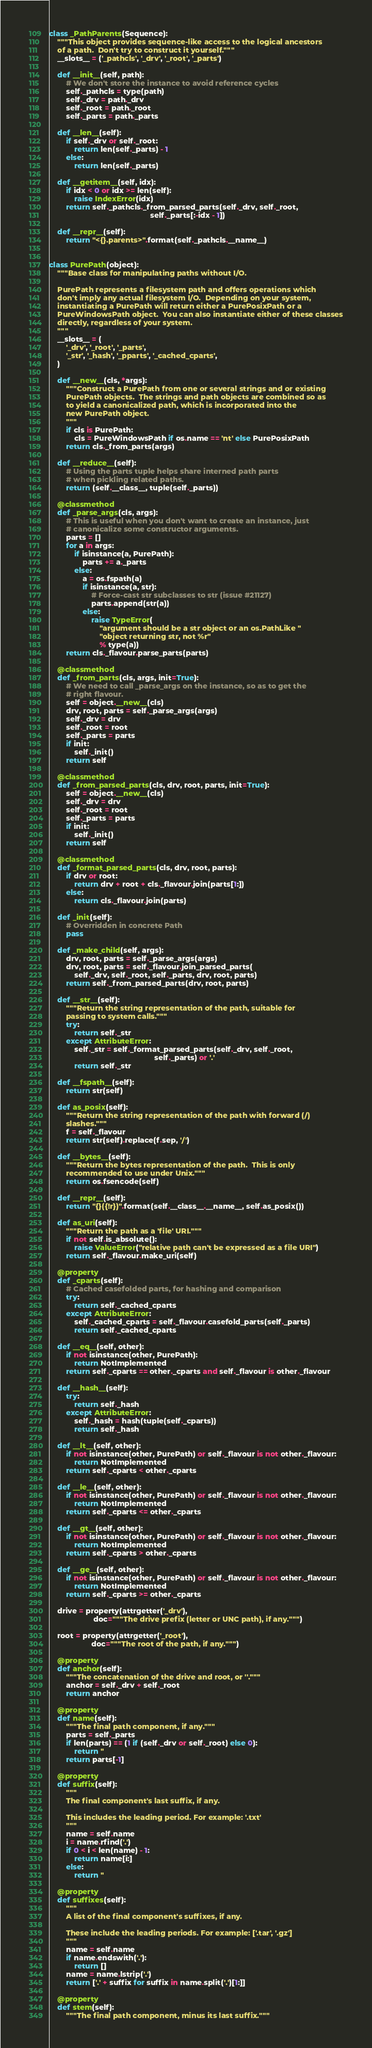Convert code to text. <code><loc_0><loc_0><loc_500><loc_500><_Python_>
class _PathParents(Sequence):
    """This object provides sequence-like access to the logical ancestors
    of a path.  Don't try to construct it yourself."""
    __slots__ = ('_pathcls', '_drv', '_root', '_parts')

    def __init__(self, path):
        # We don't store the instance to avoid reference cycles
        self._pathcls = type(path)
        self._drv = path._drv
        self._root = path._root
        self._parts = path._parts

    def __len__(self):
        if self._drv or self._root:
            return len(self._parts) - 1
        else:
            return len(self._parts)

    def __getitem__(self, idx):
        if idx < 0 or idx >= len(self):
            raise IndexError(idx)
        return self._pathcls._from_parsed_parts(self._drv, self._root,
                                                self._parts[:-idx - 1])

    def __repr__(self):
        return "<{}.parents>".format(self._pathcls.__name__)


class PurePath(object):
    """Base class for manipulating paths without I/O.

    PurePath represents a filesystem path and offers operations which
    don't imply any actual filesystem I/O.  Depending on your system,
    instantiating a PurePath will return either a PurePosixPath or a
    PureWindowsPath object.  You can also instantiate either of these classes
    directly, regardless of your system.
    """
    __slots__ = (
        '_drv', '_root', '_parts',
        '_str', '_hash', '_pparts', '_cached_cparts',
    )

    def __new__(cls, *args):
        """Construct a PurePath from one or several strings and or existing
        PurePath objects.  The strings and path objects are combined so as
        to yield a canonicalized path, which is incorporated into the
        new PurePath object.
        """
        if cls is PurePath:
            cls = PureWindowsPath if os.name == 'nt' else PurePosixPath
        return cls._from_parts(args)

    def __reduce__(self):
        # Using the parts tuple helps share interned path parts
        # when pickling related paths.
        return (self.__class__, tuple(self._parts))

    @classmethod
    def _parse_args(cls, args):
        # This is useful when you don't want to create an instance, just
        # canonicalize some constructor arguments.
        parts = []
        for a in args:
            if isinstance(a, PurePath):
                parts += a._parts
            else:
                a = os.fspath(a)
                if isinstance(a, str):
                    # Force-cast str subclasses to str (issue #21127)
                    parts.append(str(a))
                else:
                    raise TypeError(
                        "argument should be a str object or an os.PathLike "
                        "object returning str, not %r"
                        % type(a))
        return cls._flavour.parse_parts(parts)

    @classmethod
    def _from_parts(cls, args, init=True):
        # We need to call _parse_args on the instance, so as to get the
        # right flavour.
        self = object.__new__(cls)
        drv, root, parts = self._parse_args(args)
        self._drv = drv
        self._root = root
        self._parts = parts
        if init:
            self._init()
        return self

    @classmethod
    def _from_parsed_parts(cls, drv, root, parts, init=True):
        self = object.__new__(cls)
        self._drv = drv
        self._root = root
        self._parts = parts
        if init:
            self._init()
        return self

    @classmethod
    def _format_parsed_parts(cls, drv, root, parts):
        if drv or root:
            return drv + root + cls._flavour.join(parts[1:])
        else:
            return cls._flavour.join(parts)

    def _init(self):
        # Overridden in concrete Path
        pass

    def _make_child(self, args):
        drv, root, parts = self._parse_args(args)
        drv, root, parts = self._flavour.join_parsed_parts(
            self._drv, self._root, self._parts, drv, root, parts)
        return self._from_parsed_parts(drv, root, parts)

    def __str__(self):
        """Return the string representation of the path, suitable for
        passing to system calls."""
        try:
            return self._str
        except AttributeError:
            self._str = self._format_parsed_parts(self._drv, self._root,
                                                  self._parts) or '.'
            return self._str

    def __fspath__(self):
        return str(self)

    def as_posix(self):
        """Return the string representation of the path with forward (/)
        slashes."""
        f = self._flavour
        return str(self).replace(f.sep, '/')

    def __bytes__(self):
        """Return the bytes representation of the path.  This is only
        recommended to use under Unix."""
        return os.fsencode(self)

    def __repr__(self):
        return "{}({!r})".format(self.__class__.__name__, self.as_posix())

    def as_uri(self):
        """Return the path as a 'file' URI."""
        if not self.is_absolute():
            raise ValueError("relative path can't be expressed as a file URI")
        return self._flavour.make_uri(self)

    @property
    def _cparts(self):
        # Cached casefolded parts, for hashing and comparison
        try:
            return self._cached_cparts
        except AttributeError:
            self._cached_cparts = self._flavour.casefold_parts(self._parts)
            return self._cached_cparts

    def __eq__(self, other):
        if not isinstance(other, PurePath):
            return NotImplemented
        return self._cparts == other._cparts and self._flavour is other._flavour

    def __hash__(self):
        try:
            return self._hash
        except AttributeError:
            self._hash = hash(tuple(self._cparts))
            return self._hash

    def __lt__(self, other):
        if not isinstance(other, PurePath) or self._flavour is not other._flavour:
            return NotImplemented
        return self._cparts < other._cparts

    def __le__(self, other):
        if not isinstance(other, PurePath) or self._flavour is not other._flavour:
            return NotImplemented
        return self._cparts <= other._cparts

    def __gt__(self, other):
        if not isinstance(other, PurePath) or self._flavour is not other._flavour:
            return NotImplemented
        return self._cparts > other._cparts

    def __ge__(self, other):
        if not isinstance(other, PurePath) or self._flavour is not other._flavour:
            return NotImplemented
        return self._cparts >= other._cparts

    drive = property(attrgetter('_drv'),
                     doc="""The drive prefix (letter or UNC path), if any.""")

    root = property(attrgetter('_root'),
                    doc="""The root of the path, if any.""")

    @property
    def anchor(self):
        """The concatenation of the drive and root, or ''."""
        anchor = self._drv + self._root
        return anchor

    @property
    def name(self):
        """The final path component, if any."""
        parts = self._parts
        if len(parts) == (1 if (self._drv or self._root) else 0):
            return ''
        return parts[-1]

    @property
    def suffix(self):
        """
        The final component's last suffix, if any.

        This includes the leading period. For example: '.txt'
        """
        name = self.name
        i = name.rfind('.')
        if 0 < i < len(name) - 1:
            return name[i:]
        else:
            return ''

    @property
    def suffixes(self):
        """
        A list of the final component's suffixes, if any.

        These include the leading periods. For example: ['.tar', '.gz']
        """
        name = self.name
        if name.endswith('.'):
            return []
        name = name.lstrip('.')
        return ['.' + suffix for suffix in name.split('.')[1:]]

    @property
    def stem(self):
        """The final path component, minus its last suffix."""</code> 